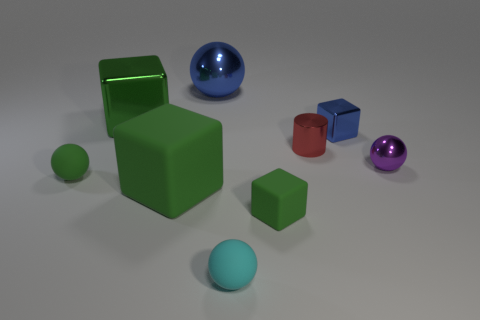Add 1 blue balls. How many objects exist? 10 Subtract all small metal spheres. How many spheres are left? 3 Subtract all cyan balls. How many balls are left? 3 Subtract 2 balls. How many balls are left? 2 Subtract all purple balls. Subtract all brown cylinders. How many balls are left? 3 Subtract all yellow balls. How many green blocks are left? 3 Subtract all matte objects. Subtract all cubes. How many objects are left? 1 Add 5 blue balls. How many blue balls are left? 6 Add 4 metallic things. How many metallic things exist? 9 Subtract 0 gray cylinders. How many objects are left? 9 